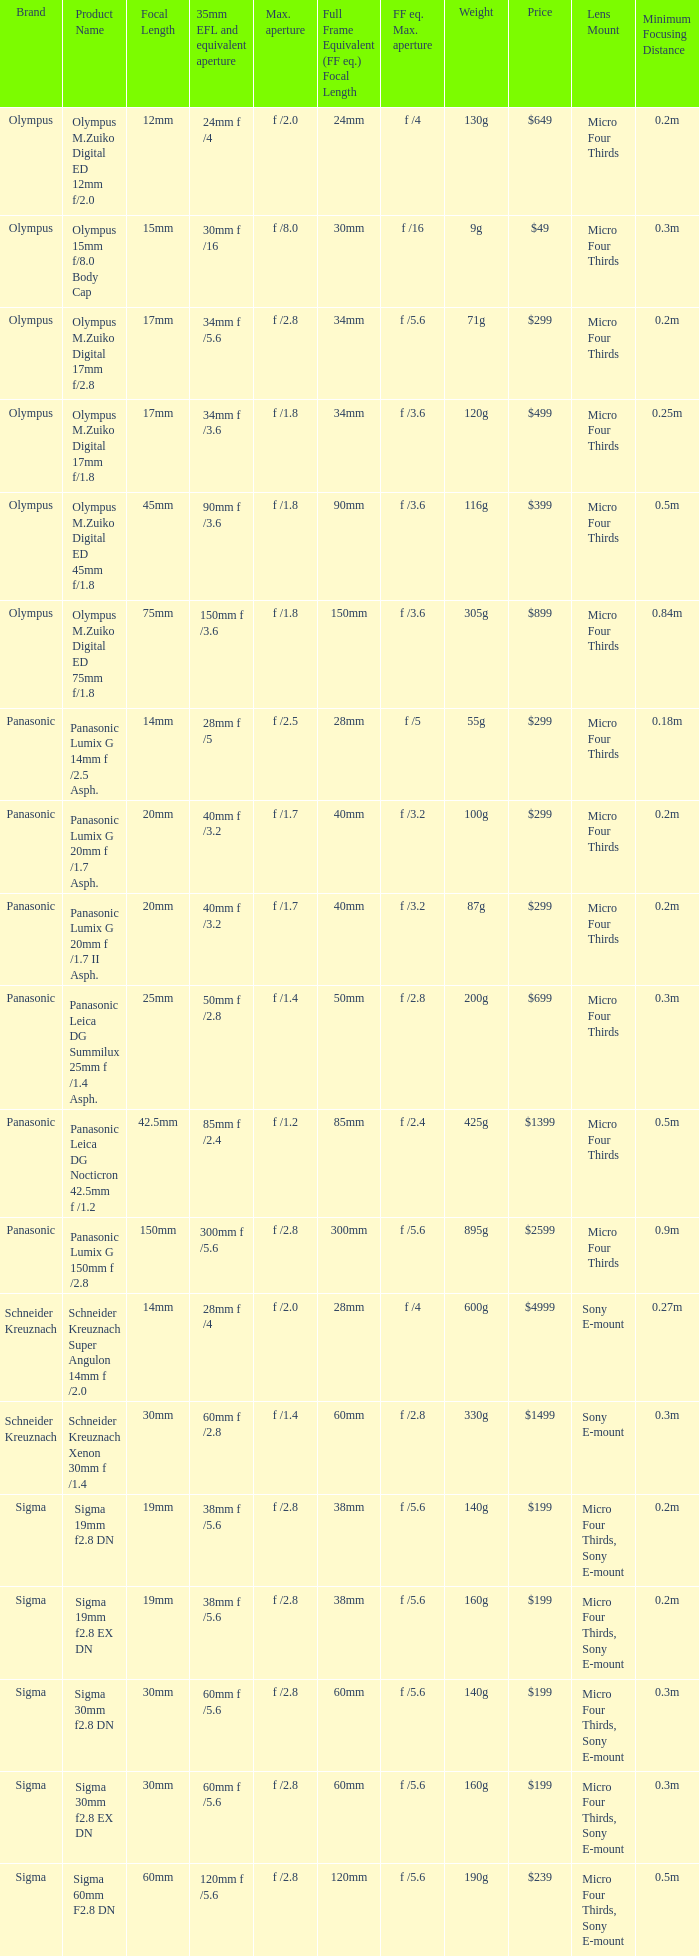What is the 35mm EFL and the equivalent aperture of the lens(es) with a maximum aperture of f /2.5? 28mm f /5. 